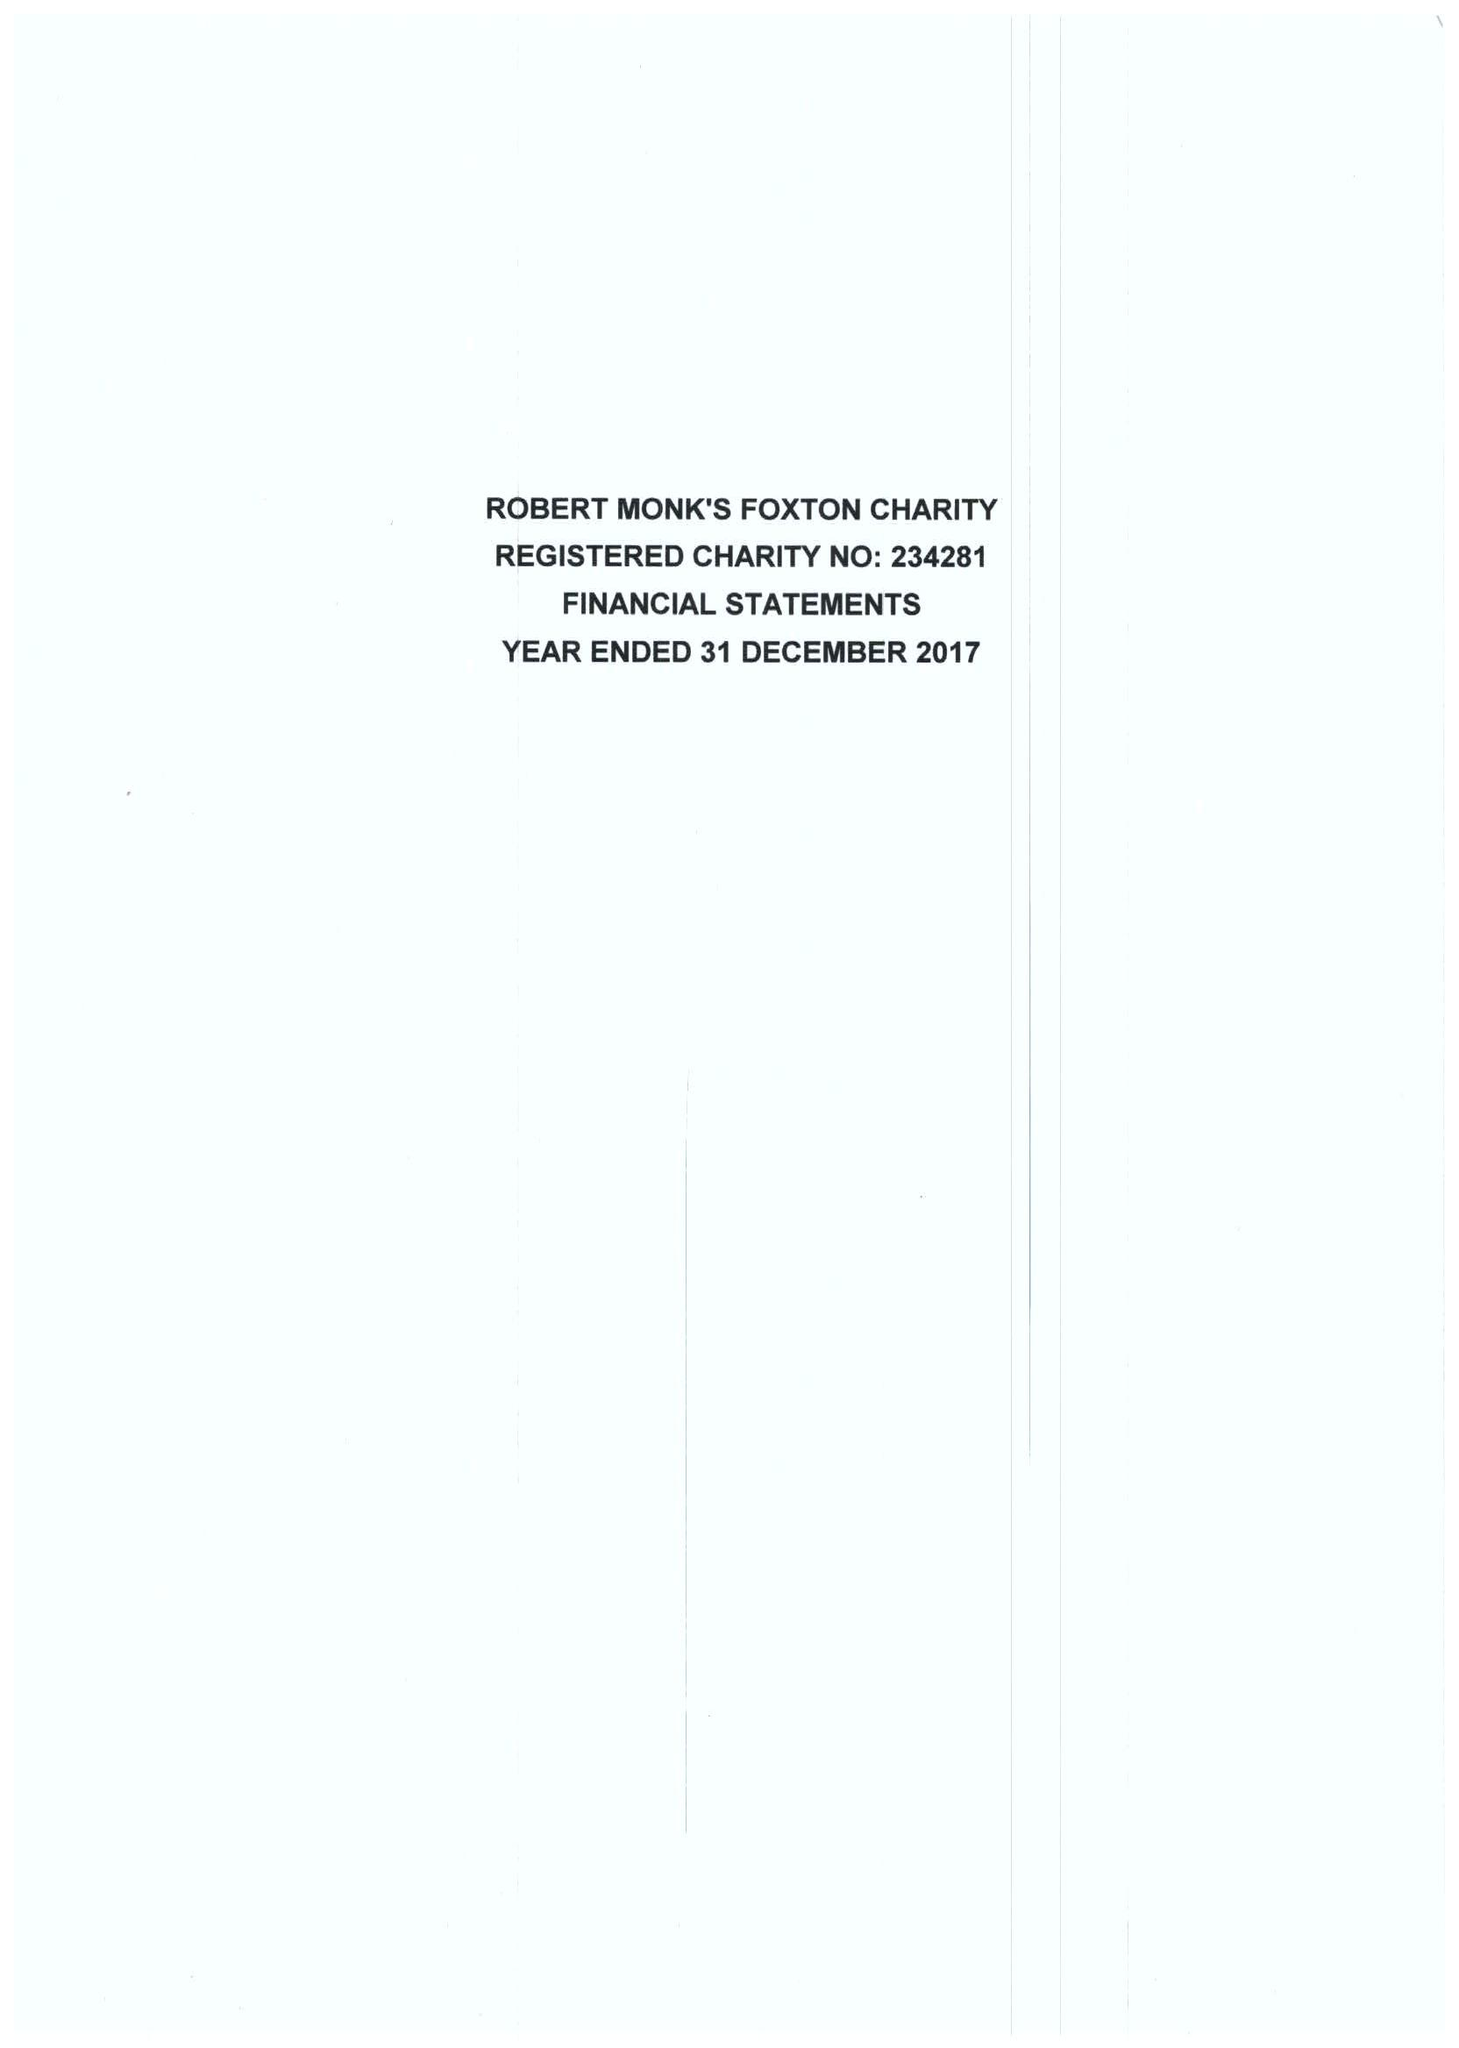What is the value for the income_annually_in_british_pounds?
Answer the question using a single word or phrase. 38772.00 